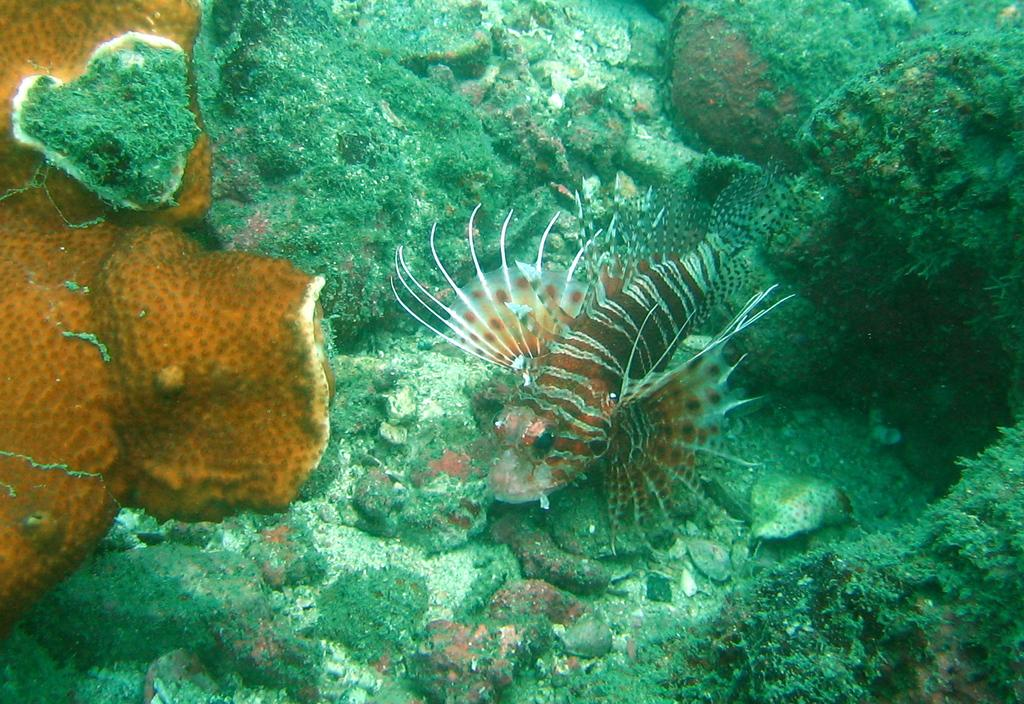What type of animal is in the image? There is a fish in the image. Where is the fish located? The fish is underwater. What else can be seen in the underwater environment? There are aquatic plants in the image. What type of house is visible in the image? There is no house present in the image; it features a fish underwater with aquatic plants. 